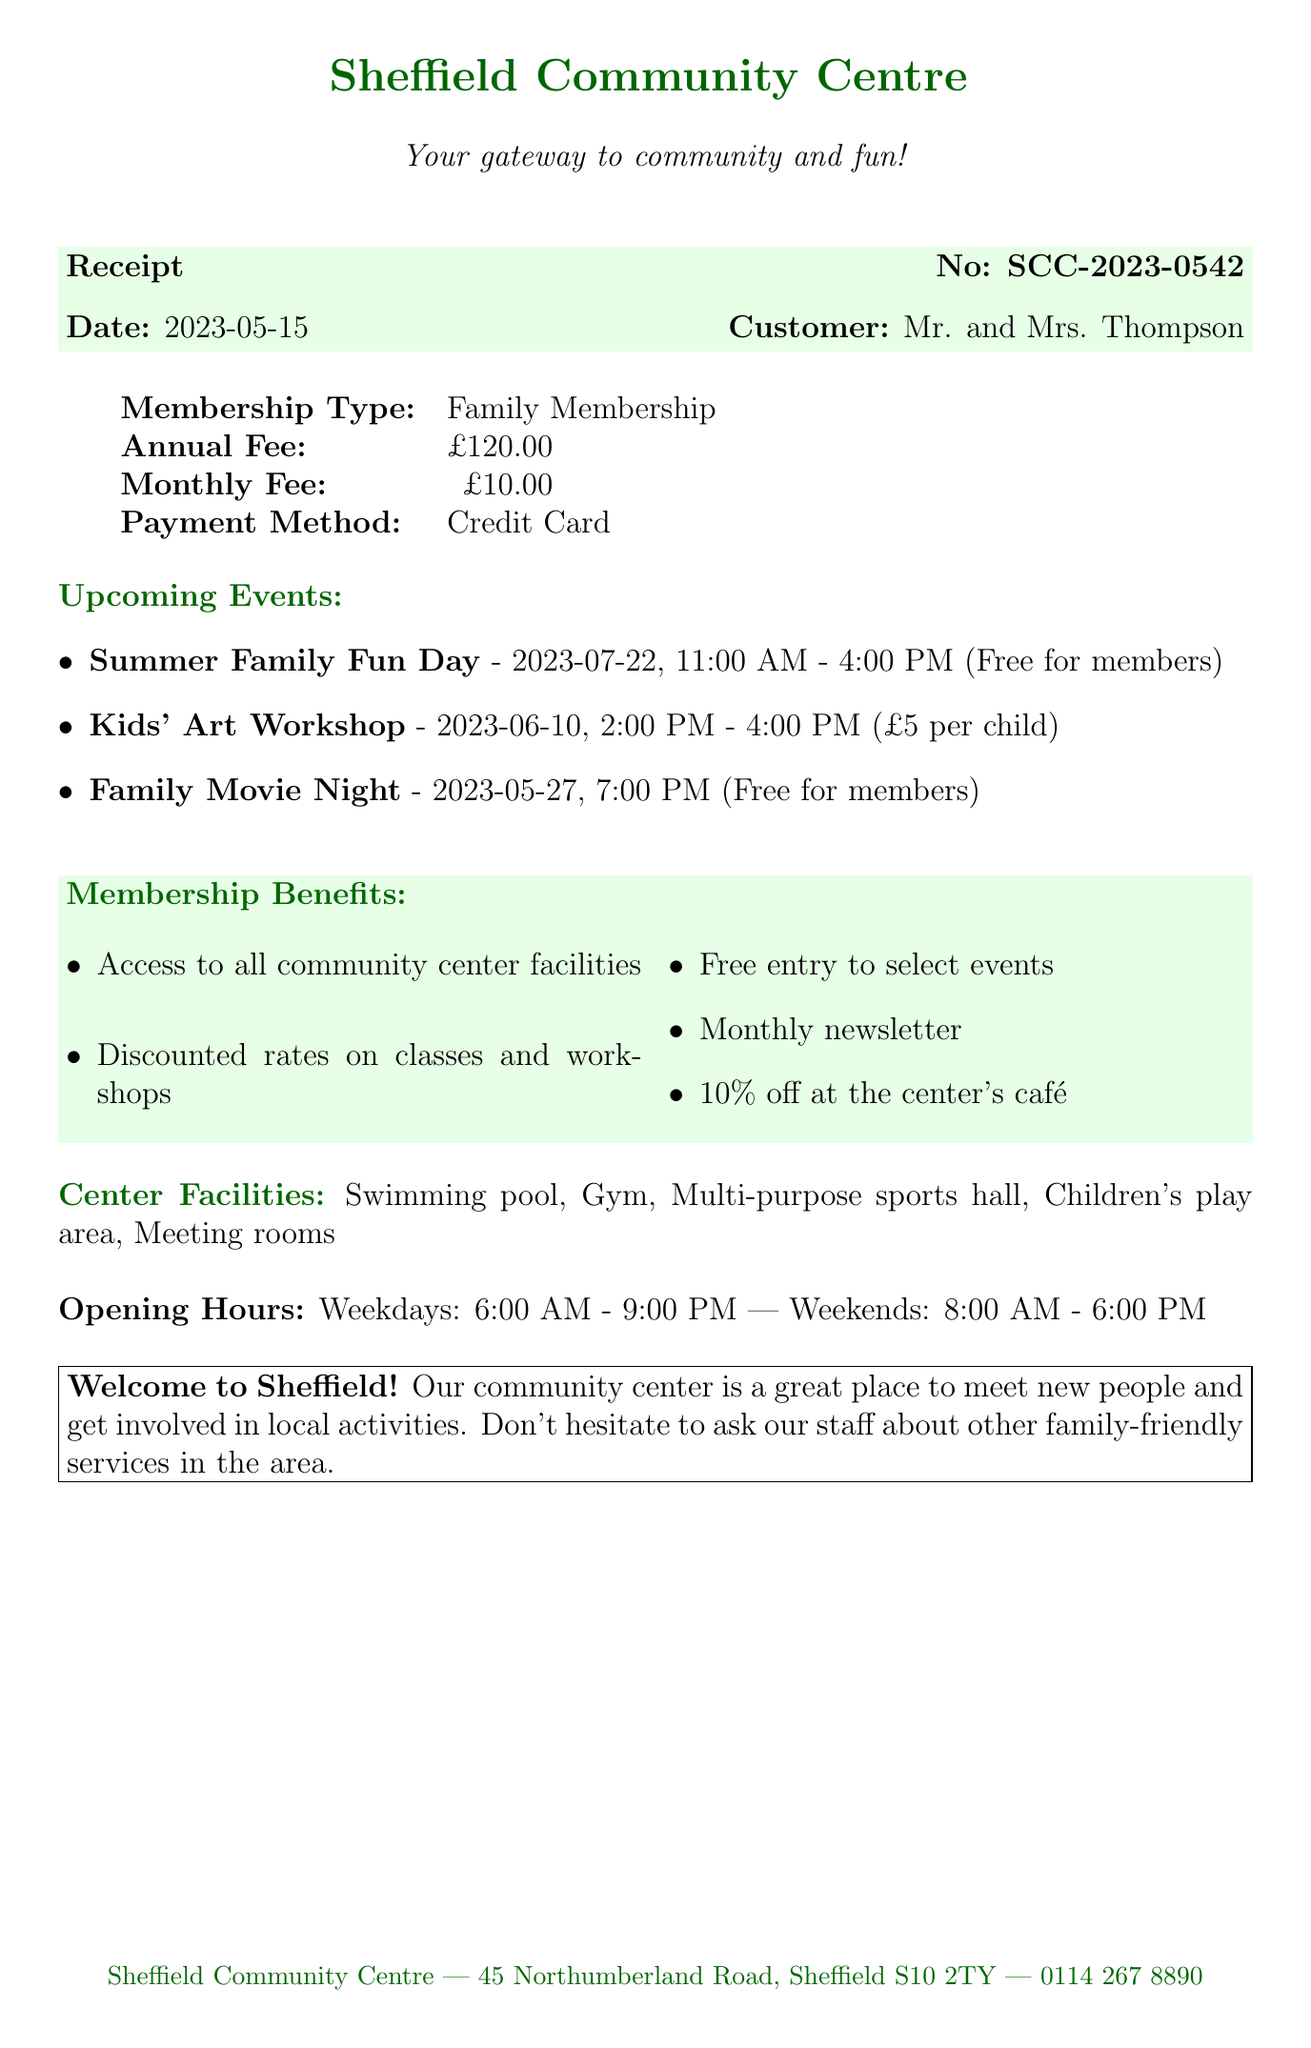What is the receipt number? The receipt number is a unique identifier for the transaction. It is listed at the top of the receipt.
Answer: SCC-2023-0542 What is the annual membership fee? The annual membership fee is specified in the document as part of the membership details.
Answer: £120.00 When is the Family Movie Night? The date and time for the Family Movie Night is provided in the list of upcoming events.
Answer: 2023-05-27, 7:00 PM What benefit is offered to members at the café? The document lists specific benefits for members, including discounts at the café.
Answer: 10% off How long is the community center open on weekends? The opening hours for weekends are provided in the document.
Answer: 10 hours What type of membership did Mr. and Mrs. Thompson purchase? The membership type is clearly indicated near the top of the receipt.
Answer: Family Membership How much does the Kids' Art Workshop cost per child? The cost for the Kids' Art Workshop is stated along with the event details.
Answer: £5 per child What facility is NOT mentioned in the center's facilities? The question asks for reasoning by considering what facilities are mentioned versus what might be expected.
Answer: N/A (any expected facility not listed) 